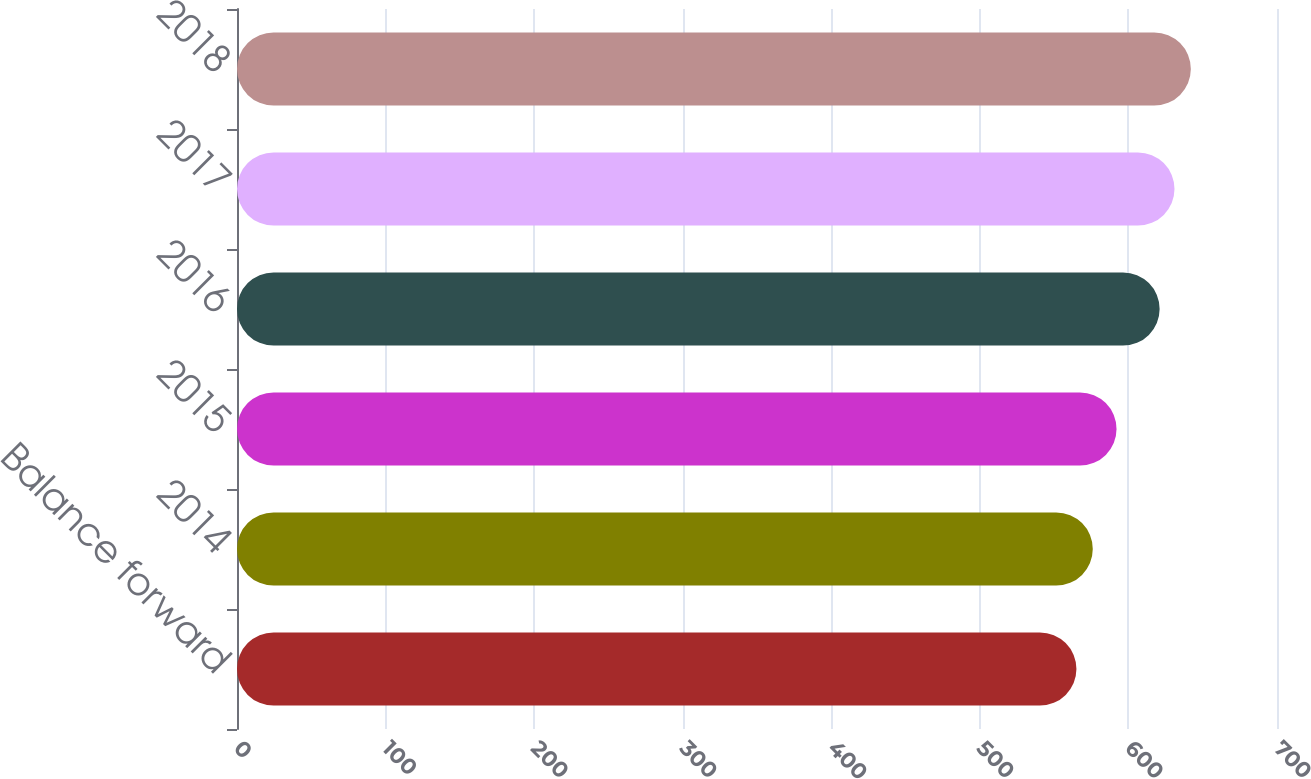<chart> <loc_0><loc_0><loc_500><loc_500><bar_chart><fcel>Balance forward<fcel>2014<fcel>2015<fcel>2016<fcel>2017<fcel>2018<nl><fcel>565<fcel>576<fcel>592<fcel>621<fcel>631<fcel>642<nl></chart> 